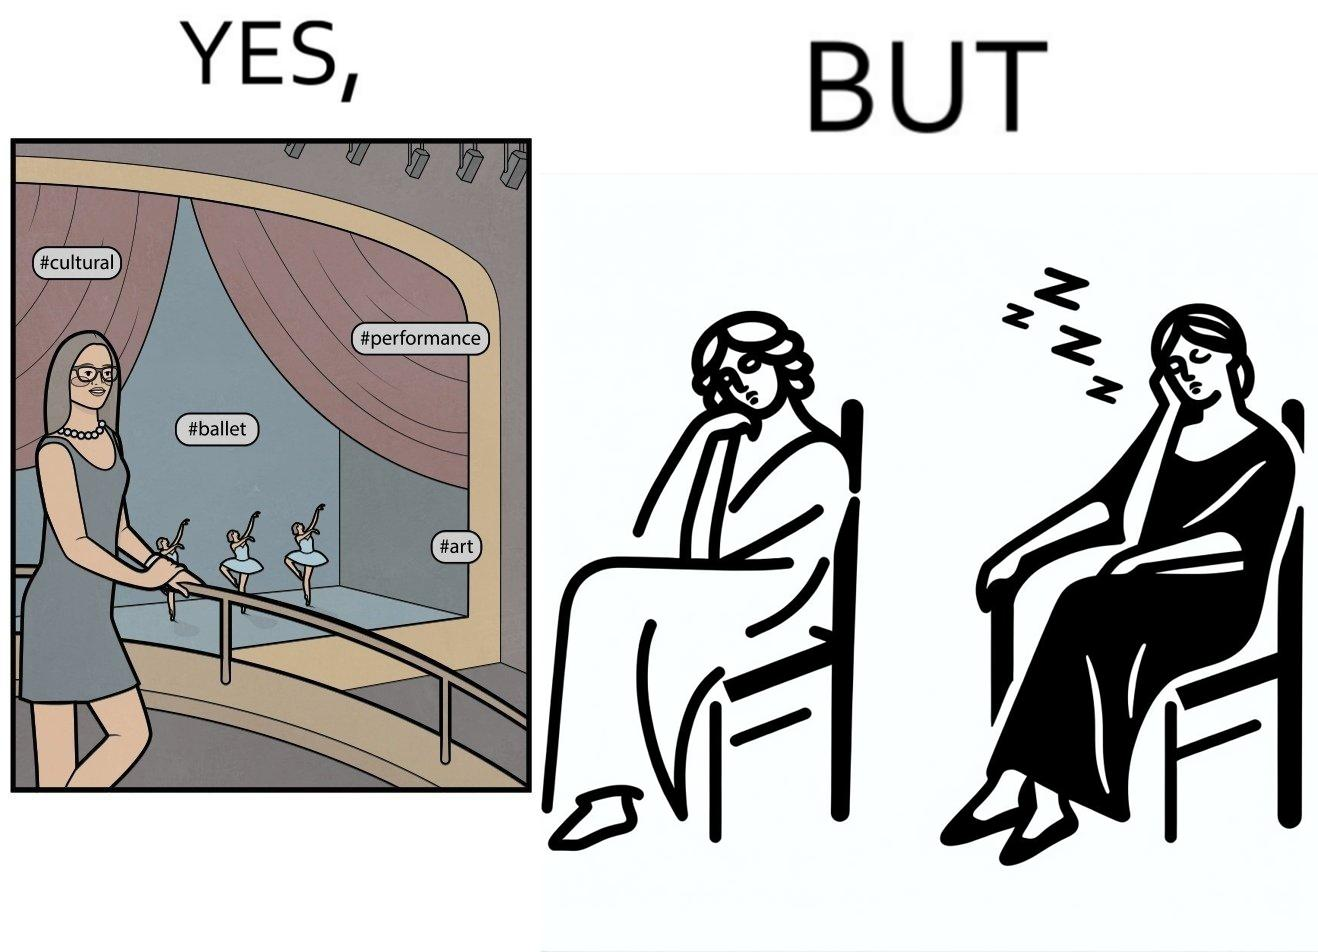Explain the humor or irony in this image. The image is ironic, because in the first image the woman is trying to show off how much she likes ballet dance performance by posting a photo attending some program but in the same program she is seen sleeping on the chair 